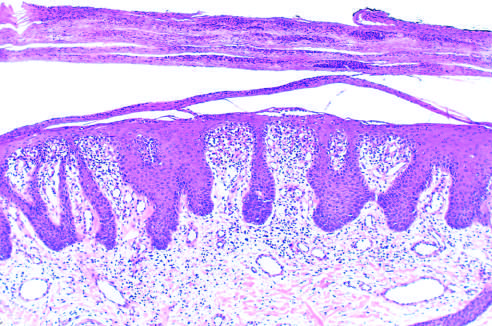what shows marked epidermal hyperplasia, downward extension of rete ridges psoriasiform hyperplasia, and prominent parakeratotic scale with infiltrating neutrophils?
Answer the question using a single word or phrase. Microscopic examination 